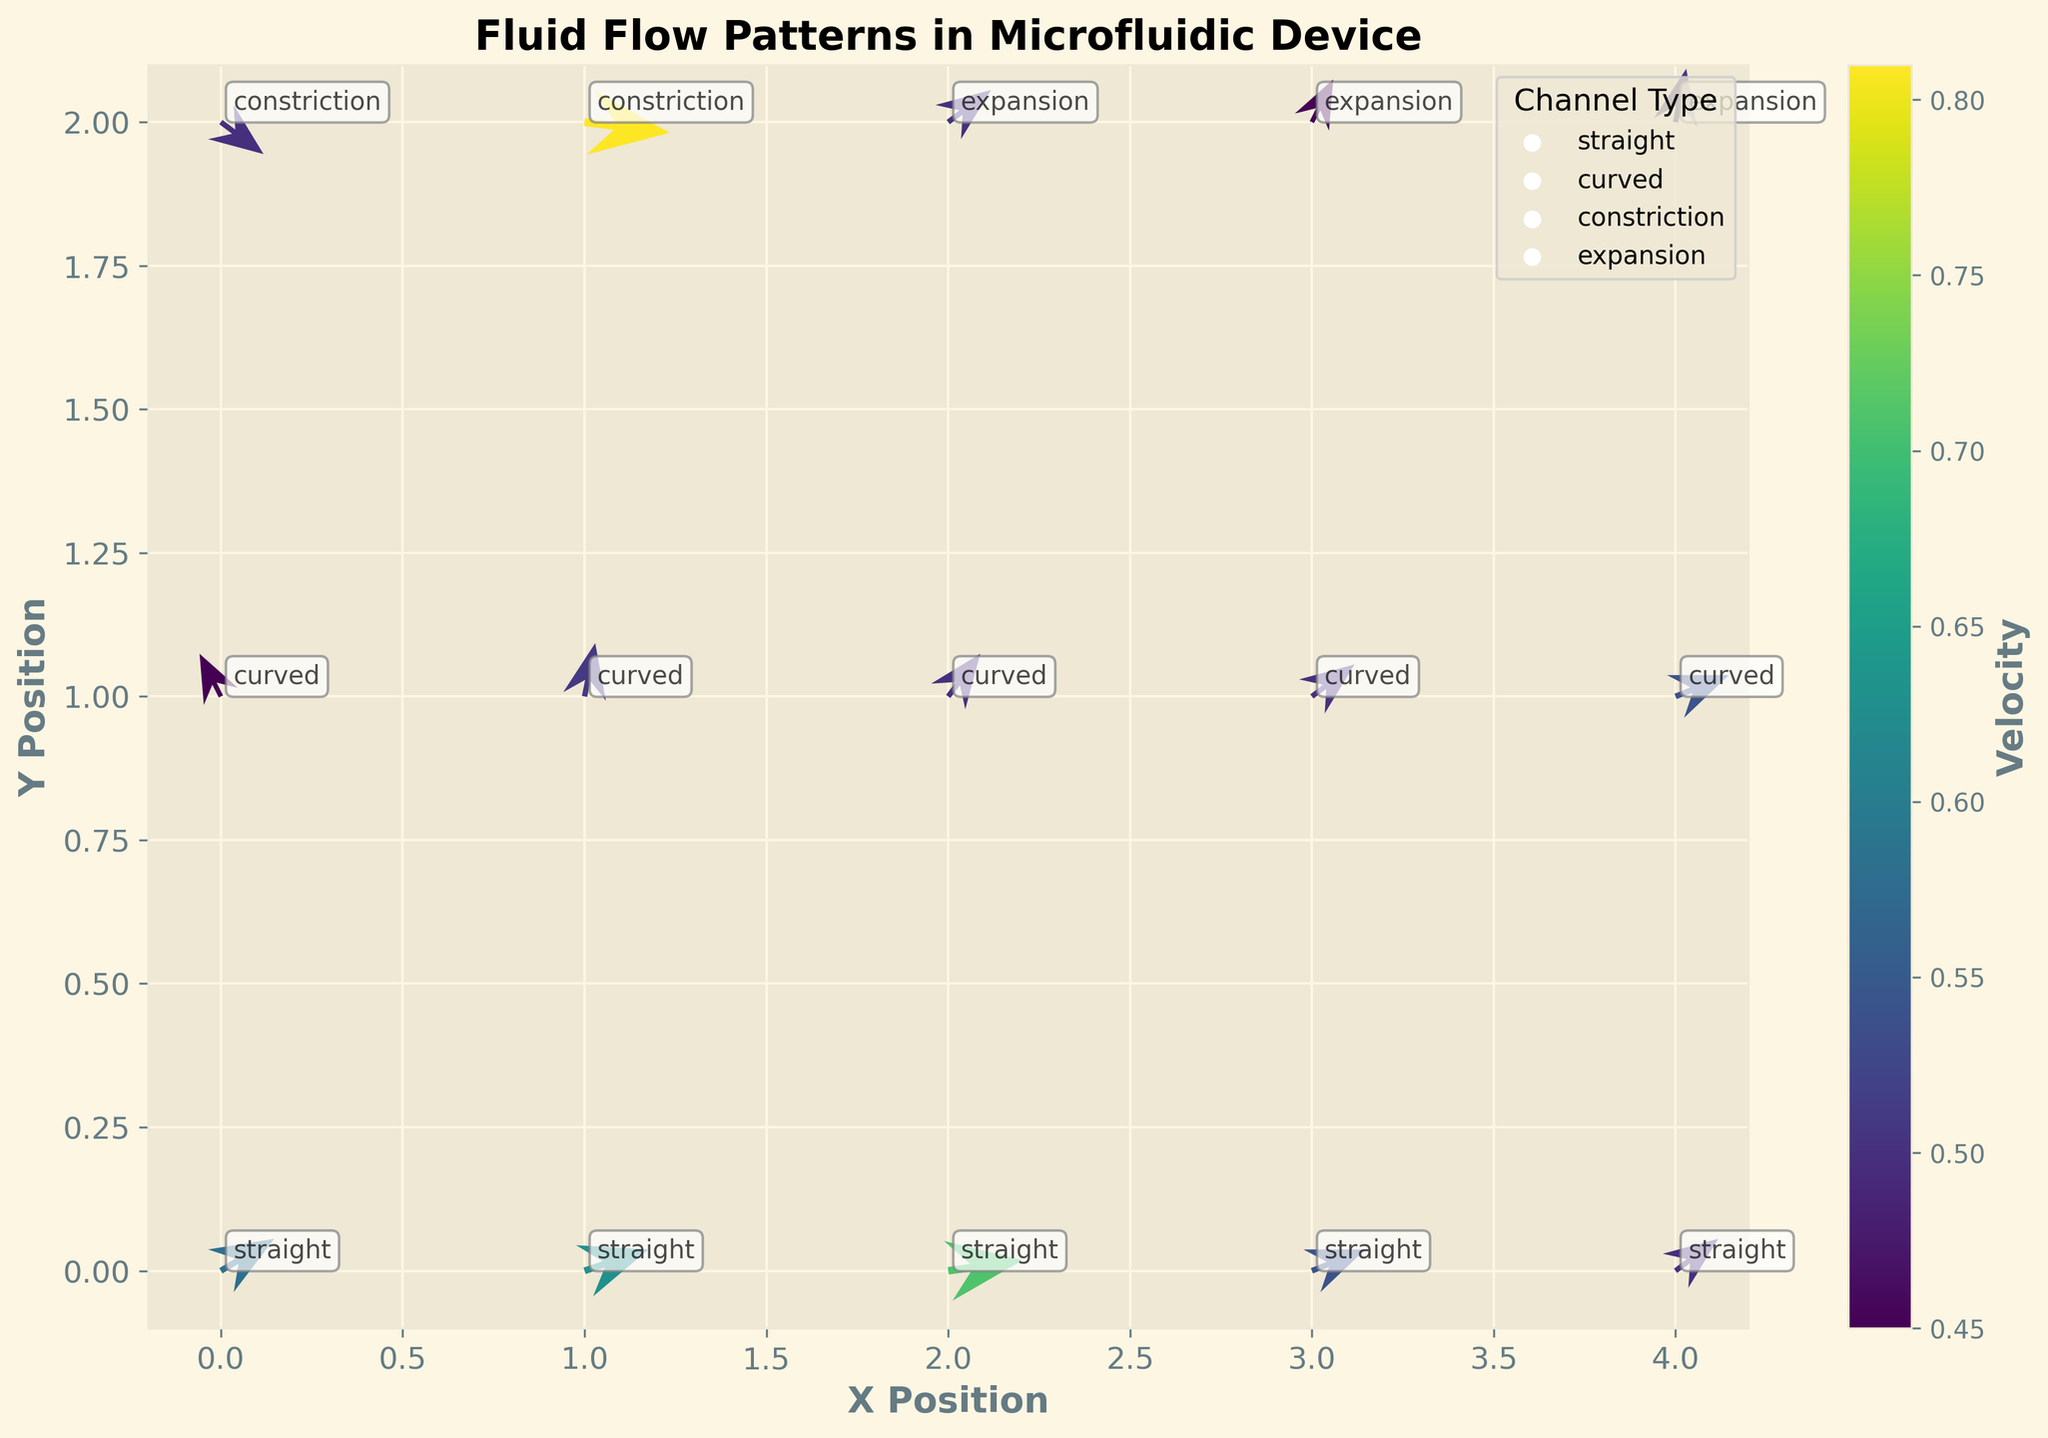What is the title of the figure? The title of the figure is displayed at the top in bold text. It describes the content of the plot.
Answer: Fluid Flow Patterns in Microfluidic Device What does the color of the arrows represent? The color of the arrows represents the velocity of the fluid flow, which is indicated by the color scale (colorbar) on the right side of the figure.
Answer: Velocity Which channel type appears at position (1,1)? The channel type at position (1,1) can be identified from the annotations provided near the data points.
Answer: Curved How many unique channel types are there in the figure? By looking at the annotation and legend, we can count the unique channel types labeled.
Answer: Four (Straight, Curved, Constriction, Expansion) Which data point has the highest velocity? By observing the color intensity in the colorbar and matching it with the arrows, the data point with the highest velocity can be identified. This is (1,2) in the constriction channel with velocity 0.81.
Answer: (1,2) in the constriction channel Compare the velocity at positions (0,1) and (2,1). Which one is higher? From the color intensity representing the velocity of each arrow, we compare the velocities at these positions.
Answer: (2,1) has a higher velocity What is the dominant direction of the fluid flow in the straight channel? The dominant direction of the fluid flow can be determined by observing the general orientation of the arrows in the straight channel sections.
Answer: Mostly right (positive x direction) In which channel type does the fluid flow show a reversal in direction? By examining the arrows' orientation carefully, we can identify that the flow direction reverses in the curved channel at position (0,1).
Answer: Curved What is the range of velocities present in the plot? The range of velocities can be inferred from the color scale (colorbar). It depicts the minimum and maximum velocities.
Answer: 0.45 to 0.81 What trend do you observe in the velocities in constriction channels? Observing the arrows and their colors in constriction channels shows that the velocity tends to increase, particularly noted at position (1,2) compared to (0,2).
Answer: Increase 